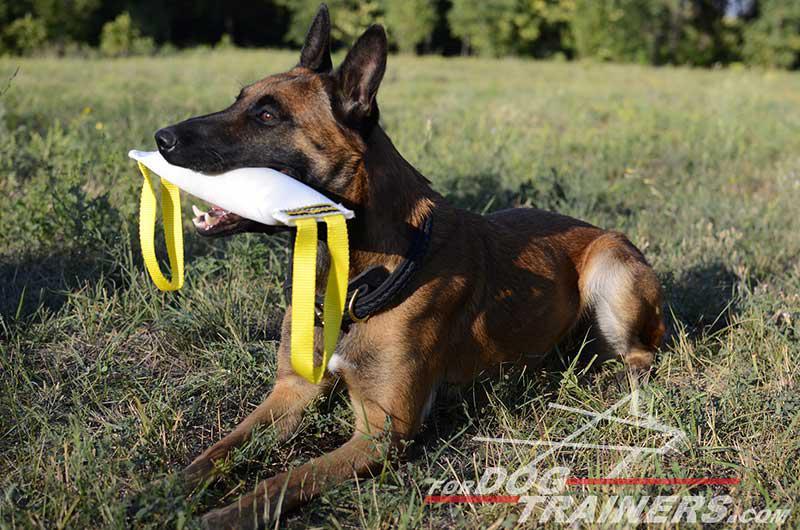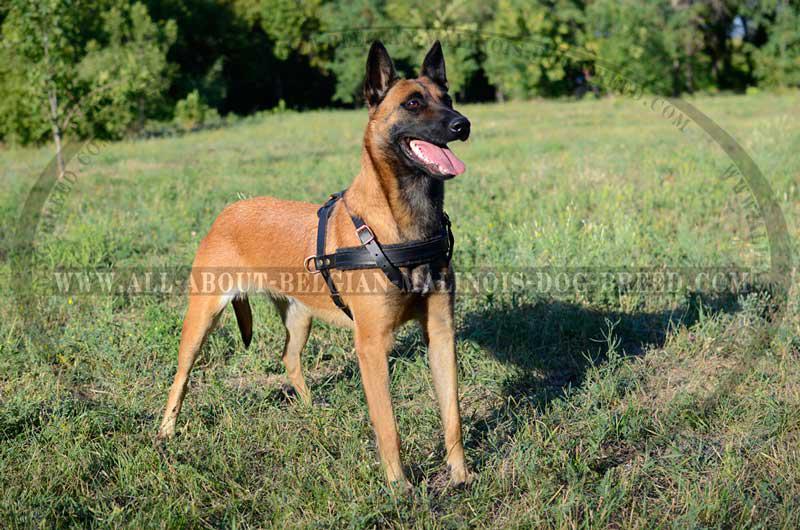The first image is the image on the left, the second image is the image on the right. For the images displayed, is the sentence "The dog on the right has an open non-snarling mouth with tongue out, and the dog on the right has something with multiple straps in front of its face that is not a dog collar." factually correct? Answer yes or no. Yes. The first image is the image on the left, the second image is the image on the right. Evaluate the accuracy of this statement regarding the images: "One of the dogs is on a leash.". Is it true? Answer yes or no. No. 